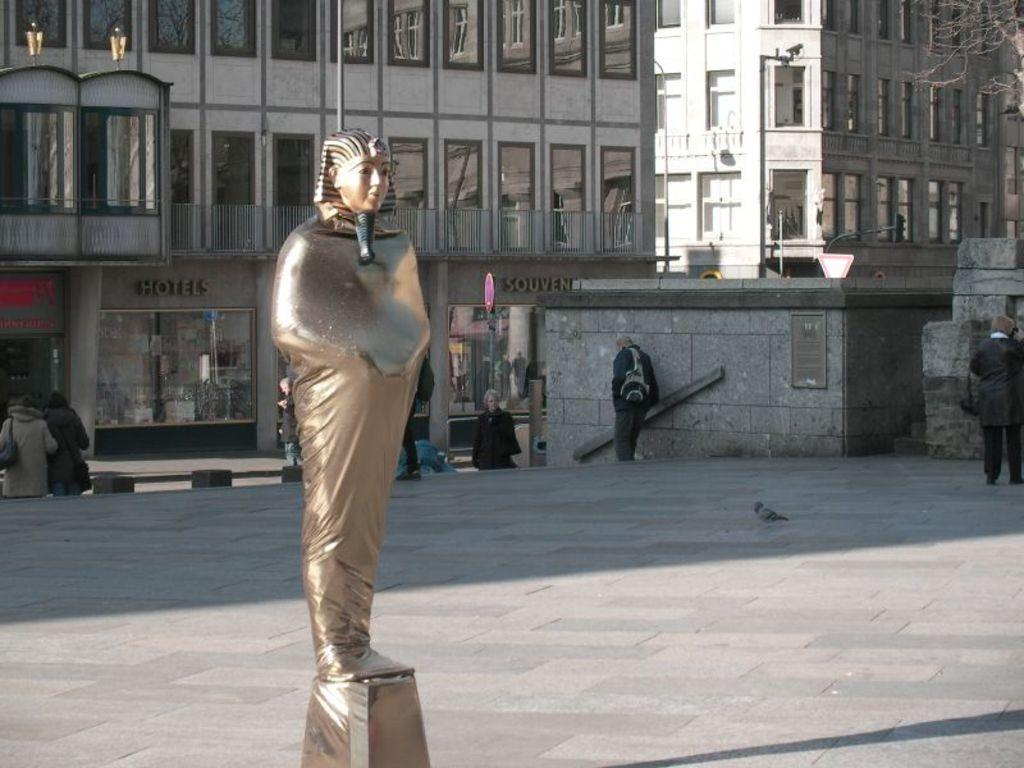What can be found on the footpath in the image? There is a statue on the footpath in the image. What else can be seen in the image? There are people standing in the image. What type of structures are visible in the background? There are buildings with windows visible in the image. What is used to provide light at night in the image? There is a street light in the image. What type of apparel is the carpenter wearing in the image? There is no carpenter present in the image, so it is not possible to determine what type of apparel they might be wearing. 